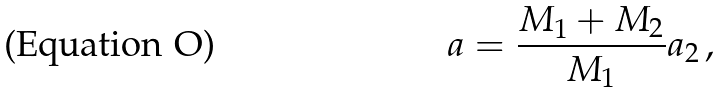<formula> <loc_0><loc_0><loc_500><loc_500>a = \frac { M _ { 1 } + M _ { 2 } } { M _ { 1 } } a _ { 2 } \, ,</formula> 